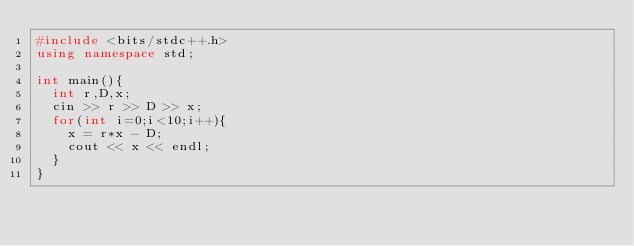<code> <loc_0><loc_0><loc_500><loc_500><_C++_>#include <bits/stdc++.h>
using namespace std;

int main(){
  int r,D,x;
  cin >> r >> D >> x;
  for(int i=0;i<10;i++){
    x = r*x - D;
    cout << x << endl;
  }
}</code> 